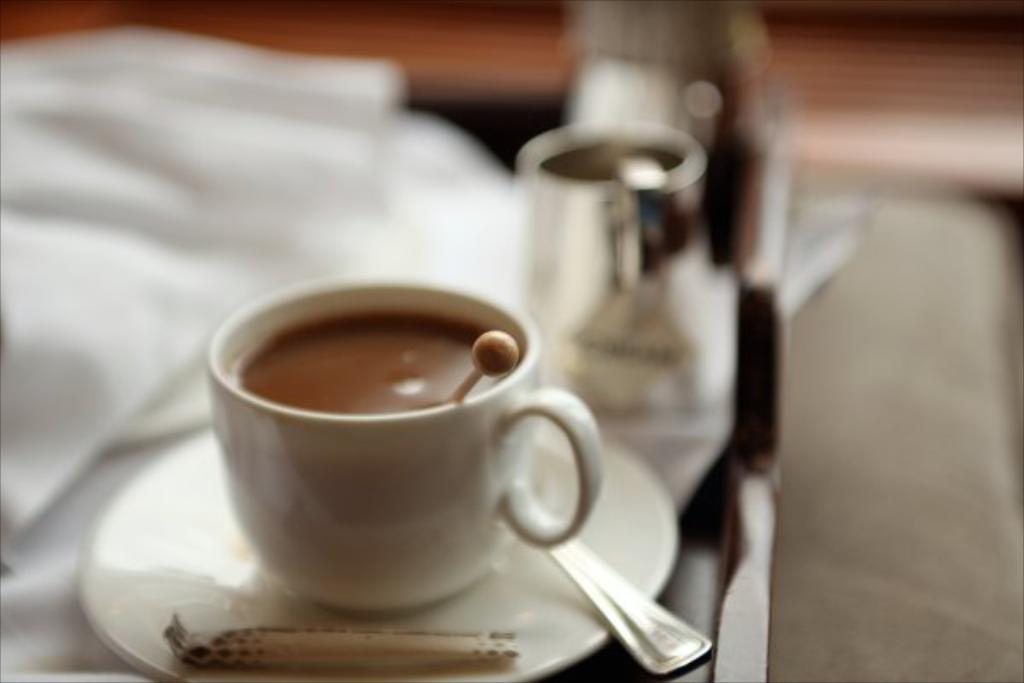What is present on the table in the image? There is a cup and a saucer on the table in the image. What is inside the cup? The cup is filled with a drink, and there is a stick in the cup. What is used to cover or protect the table surface? There is a cloth on the table. How would you describe the background of the image? The background of the image is blurry. What type of car is parked next to the table in the image? There is no car present in the image; it only features a cup, saucer, and other items on a table. 